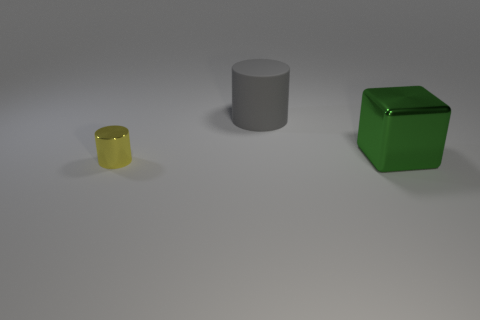Add 2 small blue things. How many objects exist? 5 Subtract all cubes. How many objects are left? 2 Subtract 0 blue cylinders. How many objects are left? 3 Subtract all big cylinders. Subtract all rubber cylinders. How many objects are left? 1 Add 3 rubber cylinders. How many rubber cylinders are left? 4 Add 3 gray things. How many gray things exist? 4 